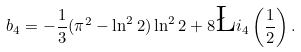Convert formula to latex. <formula><loc_0><loc_0><loc_500><loc_500>b _ { 4 } = - \frac { 1 } { 3 } ( \pi ^ { 2 } - \ln ^ { 2 } 2 ) \ln ^ { 2 } 2 + 8 \L i _ { 4 } \left ( \frac { 1 } { 2 } \right ) .</formula> 